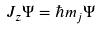Convert formula to latex. <formula><loc_0><loc_0><loc_500><loc_500>J _ { z } \Psi = \hbar { m } _ { j } \Psi</formula> 